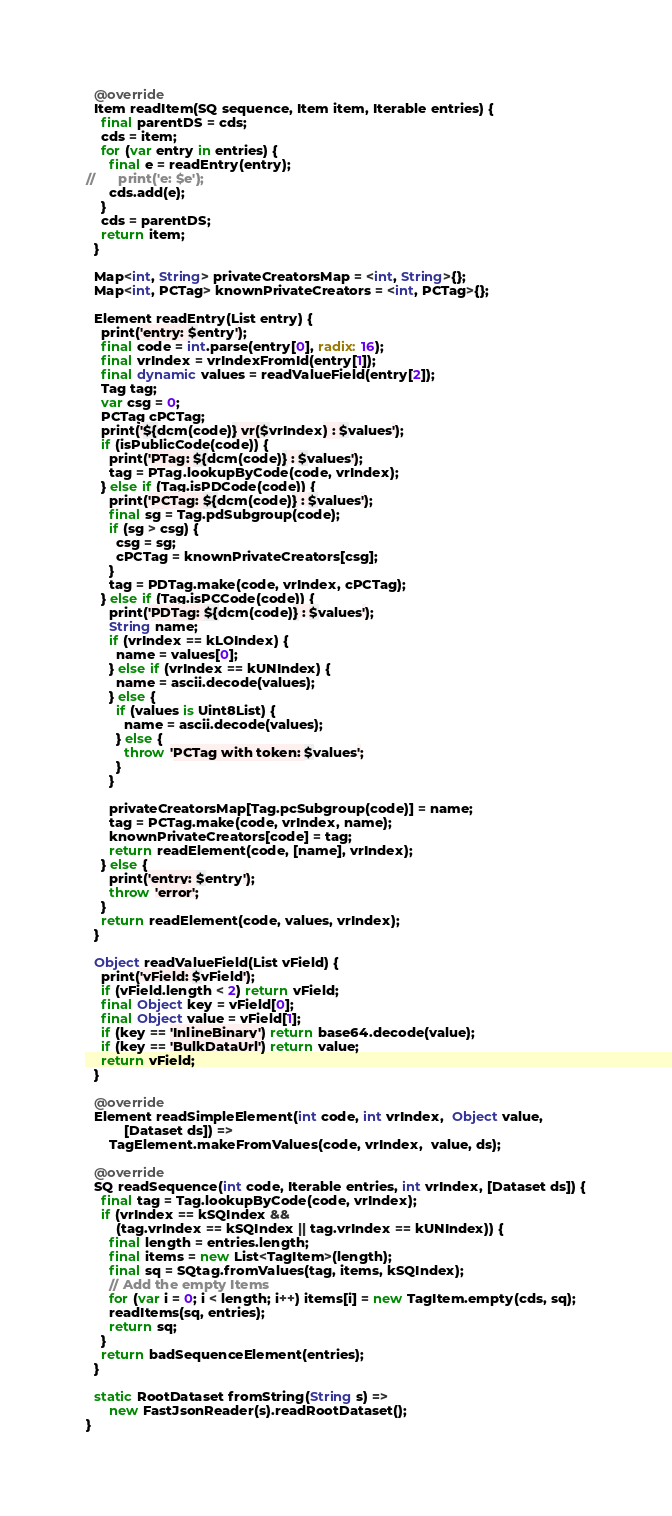Convert code to text. <code><loc_0><loc_0><loc_500><loc_500><_Dart_>  @override
  Item readItem(SQ sequence, Item item, Iterable entries) {
    final parentDS = cds;
    cds = item;
    for (var entry in entries) {
      final e = readEntry(entry);
//      print('e: $e');
      cds.add(e);
    }
    cds = parentDS;
    return item;
  }

  Map<int, String> privateCreatorsMap = <int, String>{};
  Map<int, PCTag> knownPrivateCreators = <int, PCTag>{};

  Element readEntry(List entry) {
    print('entry: $entry');
    final code = int.parse(entry[0], radix: 16);
    final vrIndex = vrIndexFromId(entry[1]);
    final dynamic values = readValueField(entry[2]);
    Tag tag;
    var csg = 0;
    PCTag cPCTag;
    print('${dcm(code)} vr($vrIndex) : $values');
    if (isPublicCode(code)) {
      print('PTag: ${dcm(code)} : $values');
      tag = PTag.lookupByCode(code, vrIndex);
    } else if (Tag.isPDCode(code)) {
      print('PCTag: ${dcm(code)} : $values');
      final sg = Tag.pdSubgroup(code);
      if (sg > csg) {
        csg = sg;
        cPCTag = knownPrivateCreators[csg];
      }
      tag = PDTag.make(code, vrIndex, cPCTag);
    } else if (Tag.isPCCode(code)) {
      print('PDTag: ${dcm(code)} : $values');
      String name;
      if (vrIndex == kLOIndex) {
        name = values[0];
      } else if (vrIndex == kUNIndex) {
        name = ascii.decode(values);
      } else {
        if (values is Uint8List) {
          name = ascii.decode(values);
        } else {
          throw 'PCTag with token: $values';
        }
      }

      privateCreatorsMap[Tag.pcSubgroup(code)] = name;
      tag = PCTag.make(code, vrIndex, name);
      knownPrivateCreators[code] = tag;
      return readElement(code, [name], vrIndex);
    } else {
      print('entry: $entry');
      throw 'error';
    }
    return readElement(code, values, vrIndex);
  }

  Object readValueField(List vField) {
    print('vField: $vField');
    if (vField.length < 2) return vField;
    final Object key = vField[0];
    final Object value = vField[1];
    if (key == 'InlineBinary') return base64.decode(value);
    if (key == 'BulkDataUrl') return value;
    return vField;
  }

  @override
  Element readSimpleElement(int code, int vrIndex,  Object value,
          [Dataset ds]) =>
      TagElement.makeFromValues(code, vrIndex,  value, ds);

  @override
  SQ readSequence(int code, Iterable entries, int vrIndex, [Dataset ds]) {
    final tag = Tag.lookupByCode(code, vrIndex);
    if (vrIndex == kSQIndex &&
        (tag.vrIndex == kSQIndex || tag.vrIndex == kUNIndex)) {
      final length = entries.length;
      final items = new List<TagItem>(length);
      final sq = SQtag.fromValues(tag, items, kSQIndex);
      // Add the empty Items
      for (var i = 0; i < length; i++) items[i] = new TagItem.empty(cds, sq);
      readItems(sq, entries);
      return sq;
    }
    return badSequenceElement(entries);
  }

  static RootDataset fromString(String s) =>
      new FastJsonReader(s).readRootDataset();
}
</code> 